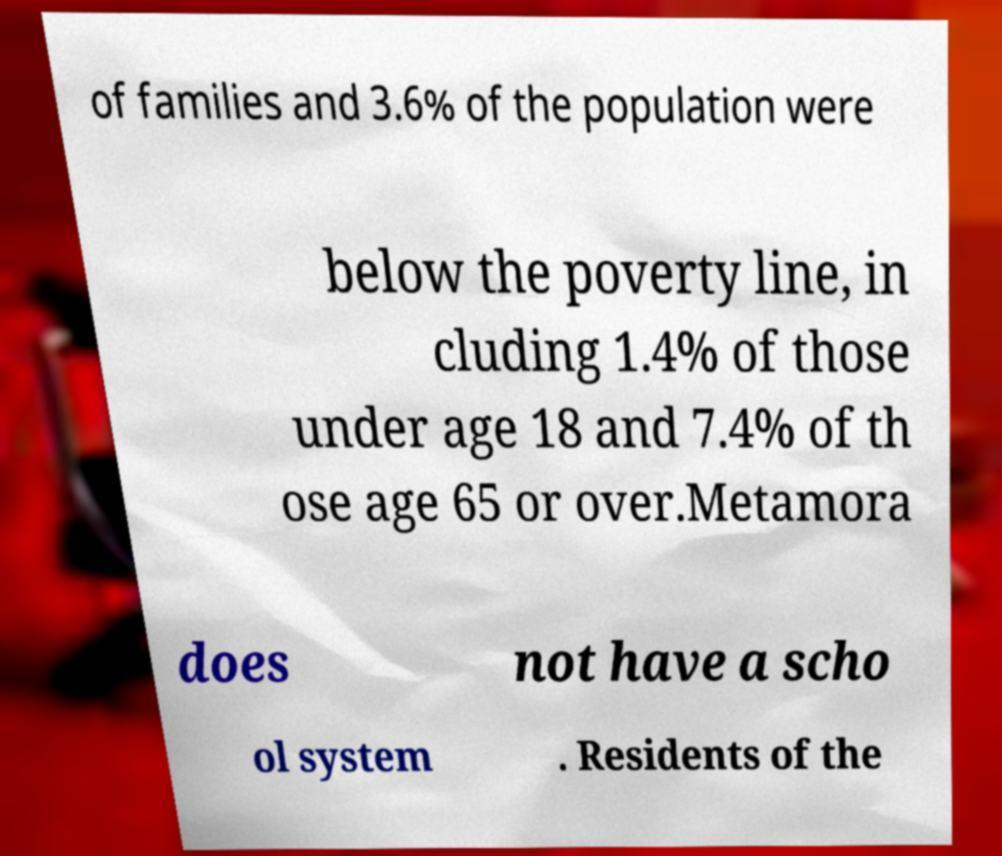Please identify and transcribe the text found in this image. of families and 3.6% of the population were below the poverty line, in cluding 1.4% of those under age 18 and 7.4% of th ose age 65 or over.Metamora does not have a scho ol system . Residents of the 